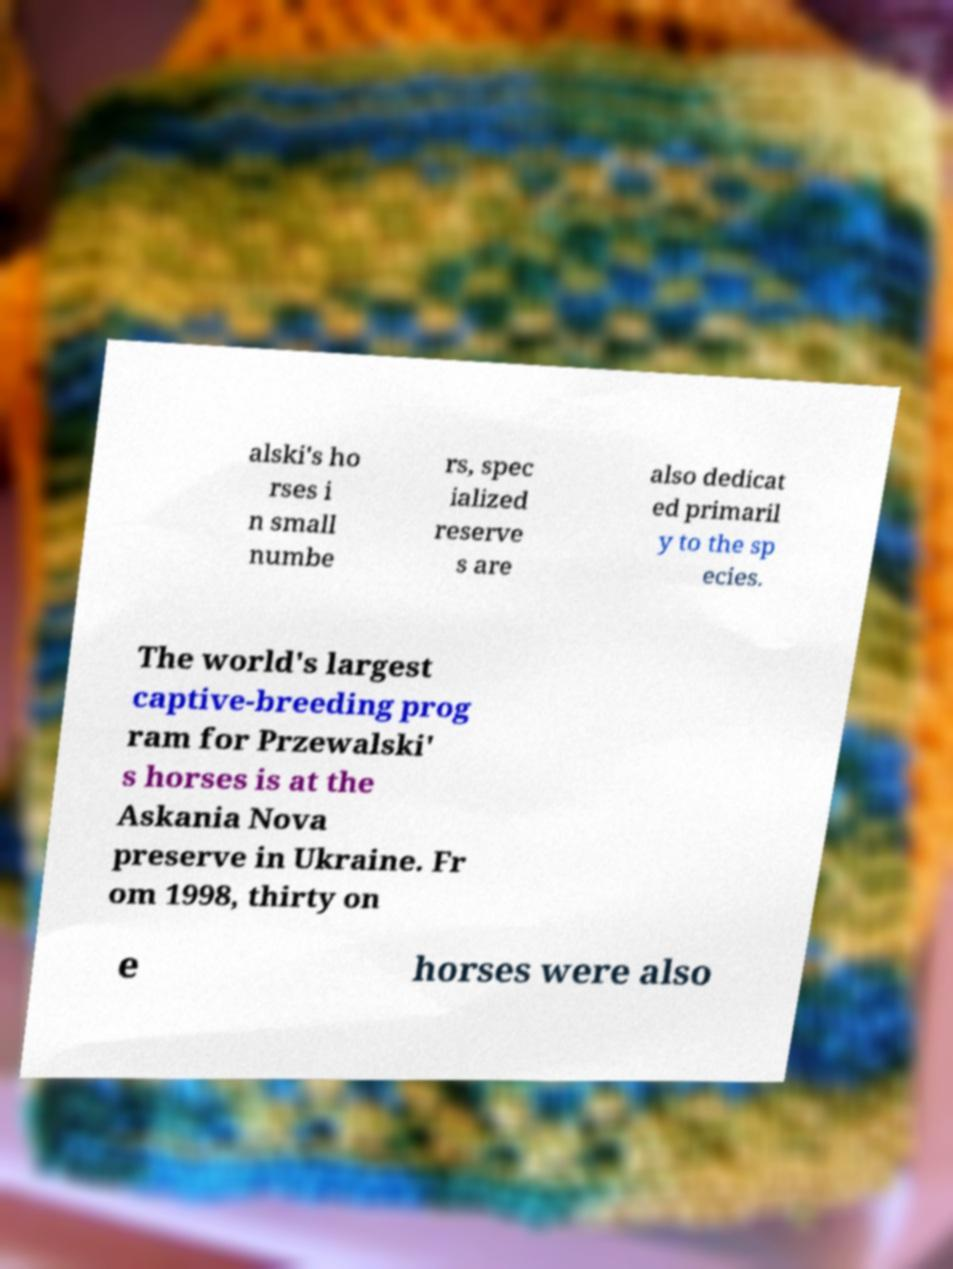I need the written content from this picture converted into text. Can you do that? alski's ho rses i n small numbe rs, spec ialized reserve s are also dedicat ed primaril y to the sp ecies. The world's largest captive-breeding prog ram for Przewalski' s horses is at the Askania Nova preserve in Ukraine. Fr om 1998, thirty on e horses were also 